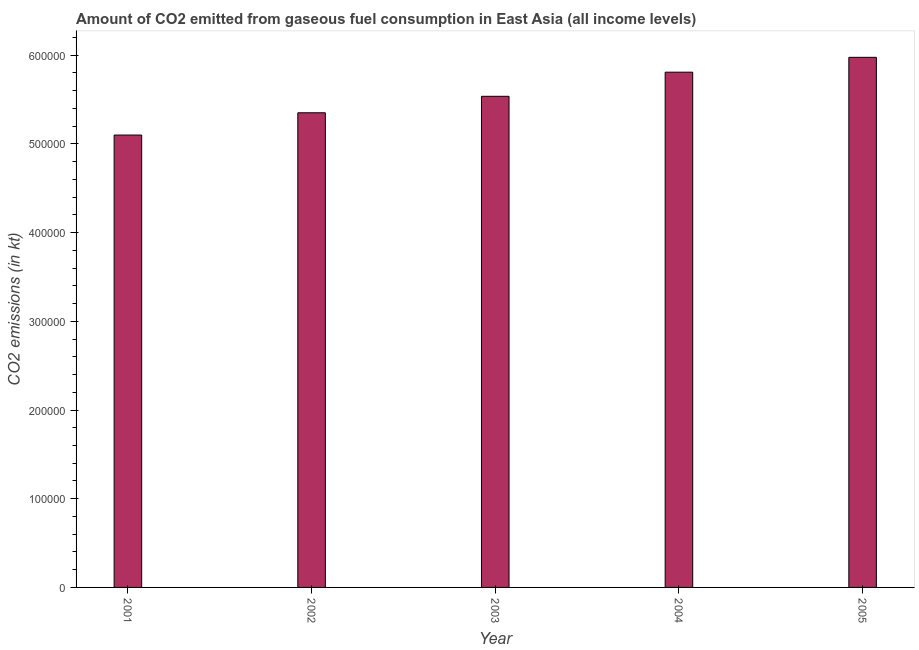Does the graph contain any zero values?
Give a very brief answer. No. What is the title of the graph?
Ensure brevity in your answer.  Amount of CO2 emitted from gaseous fuel consumption in East Asia (all income levels). What is the label or title of the X-axis?
Give a very brief answer. Year. What is the label or title of the Y-axis?
Keep it short and to the point. CO2 emissions (in kt). What is the co2 emissions from gaseous fuel consumption in 2005?
Your response must be concise. 5.98e+05. Across all years, what is the maximum co2 emissions from gaseous fuel consumption?
Your answer should be compact. 5.98e+05. Across all years, what is the minimum co2 emissions from gaseous fuel consumption?
Your answer should be very brief. 5.10e+05. In which year was the co2 emissions from gaseous fuel consumption minimum?
Offer a very short reply. 2001. What is the sum of the co2 emissions from gaseous fuel consumption?
Offer a terse response. 2.78e+06. What is the difference between the co2 emissions from gaseous fuel consumption in 2001 and 2002?
Your answer should be compact. -2.51e+04. What is the average co2 emissions from gaseous fuel consumption per year?
Keep it short and to the point. 5.55e+05. What is the median co2 emissions from gaseous fuel consumption?
Offer a very short reply. 5.54e+05. What is the ratio of the co2 emissions from gaseous fuel consumption in 2002 to that in 2005?
Your answer should be very brief. 0.9. Is the difference between the co2 emissions from gaseous fuel consumption in 2004 and 2005 greater than the difference between any two years?
Keep it short and to the point. No. What is the difference between the highest and the second highest co2 emissions from gaseous fuel consumption?
Ensure brevity in your answer.  1.67e+04. Is the sum of the co2 emissions from gaseous fuel consumption in 2002 and 2004 greater than the maximum co2 emissions from gaseous fuel consumption across all years?
Offer a terse response. Yes. What is the difference between the highest and the lowest co2 emissions from gaseous fuel consumption?
Offer a very short reply. 8.76e+04. In how many years, is the co2 emissions from gaseous fuel consumption greater than the average co2 emissions from gaseous fuel consumption taken over all years?
Ensure brevity in your answer.  2. Are all the bars in the graph horizontal?
Your answer should be compact. No. What is the difference between two consecutive major ticks on the Y-axis?
Provide a succinct answer. 1.00e+05. Are the values on the major ticks of Y-axis written in scientific E-notation?
Ensure brevity in your answer.  No. What is the CO2 emissions (in kt) of 2001?
Your response must be concise. 5.10e+05. What is the CO2 emissions (in kt) in 2002?
Your response must be concise. 5.35e+05. What is the CO2 emissions (in kt) in 2003?
Provide a short and direct response. 5.54e+05. What is the CO2 emissions (in kt) in 2004?
Your answer should be compact. 5.81e+05. What is the CO2 emissions (in kt) in 2005?
Your answer should be very brief. 5.98e+05. What is the difference between the CO2 emissions (in kt) in 2001 and 2002?
Offer a terse response. -2.51e+04. What is the difference between the CO2 emissions (in kt) in 2001 and 2003?
Provide a short and direct response. -4.37e+04. What is the difference between the CO2 emissions (in kt) in 2001 and 2004?
Offer a terse response. -7.09e+04. What is the difference between the CO2 emissions (in kt) in 2001 and 2005?
Give a very brief answer. -8.76e+04. What is the difference between the CO2 emissions (in kt) in 2002 and 2003?
Ensure brevity in your answer.  -1.86e+04. What is the difference between the CO2 emissions (in kt) in 2002 and 2004?
Provide a succinct answer. -4.58e+04. What is the difference between the CO2 emissions (in kt) in 2002 and 2005?
Offer a terse response. -6.25e+04. What is the difference between the CO2 emissions (in kt) in 2003 and 2004?
Make the answer very short. -2.72e+04. What is the difference between the CO2 emissions (in kt) in 2003 and 2005?
Give a very brief answer. -4.39e+04. What is the difference between the CO2 emissions (in kt) in 2004 and 2005?
Provide a short and direct response. -1.67e+04. What is the ratio of the CO2 emissions (in kt) in 2001 to that in 2002?
Make the answer very short. 0.95. What is the ratio of the CO2 emissions (in kt) in 2001 to that in 2003?
Provide a succinct answer. 0.92. What is the ratio of the CO2 emissions (in kt) in 2001 to that in 2004?
Your response must be concise. 0.88. What is the ratio of the CO2 emissions (in kt) in 2001 to that in 2005?
Provide a succinct answer. 0.85. What is the ratio of the CO2 emissions (in kt) in 2002 to that in 2004?
Provide a succinct answer. 0.92. What is the ratio of the CO2 emissions (in kt) in 2002 to that in 2005?
Ensure brevity in your answer.  0.9. What is the ratio of the CO2 emissions (in kt) in 2003 to that in 2004?
Provide a succinct answer. 0.95. What is the ratio of the CO2 emissions (in kt) in 2003 to that in 2005?
Provide a succinct answer. 0.93. 